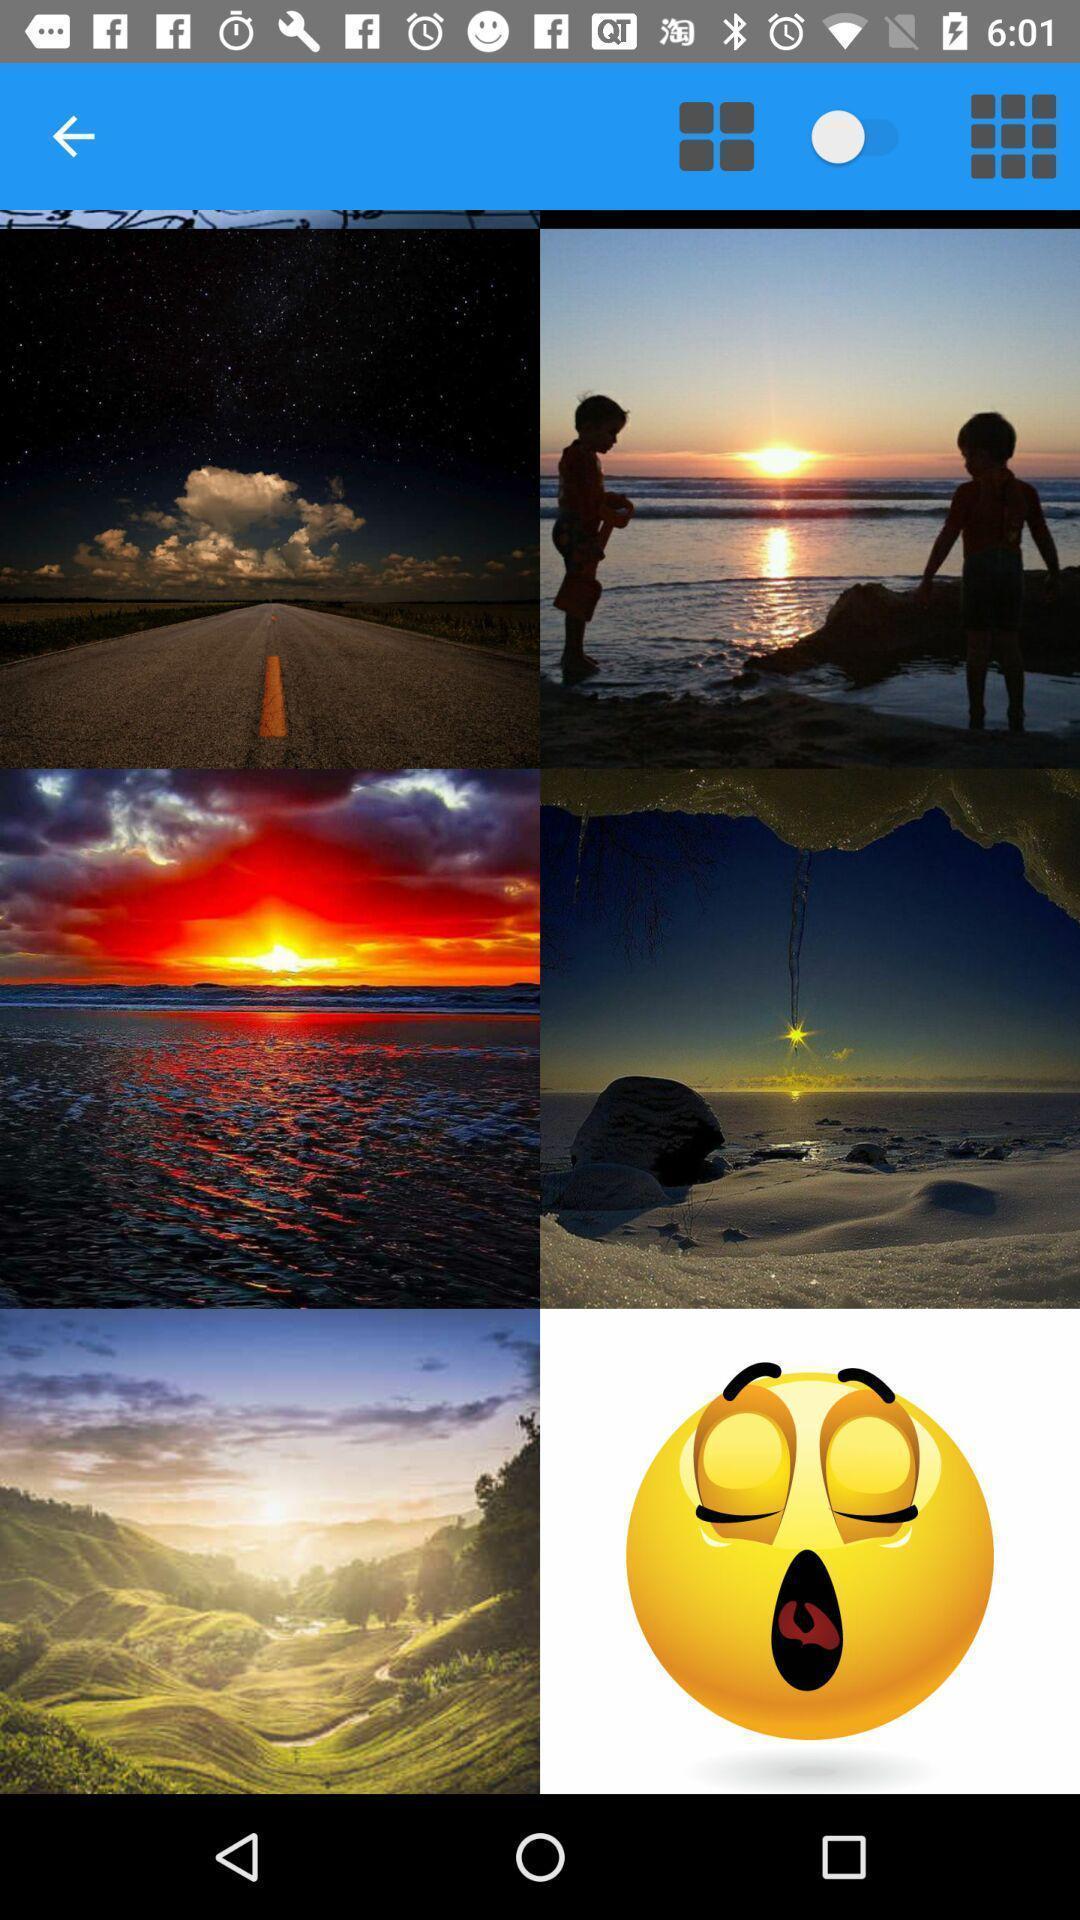Give me a summary of this screen capture. Screen showing images. 